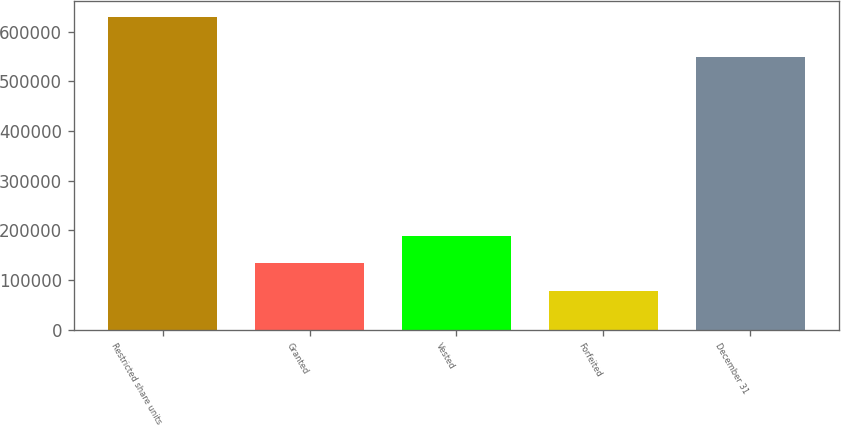Convert chart. <chart><loc_0><loc_0><loc_500><loc_500><bar_chart><fcel>Restricted share units<fcel>Granted<fcel>Vested<fcel>Forfeited<fcel>December 31<nl><fcel>630212<fcel>133838<fcel>188990<fcel>78685<fcel>548354<nl></chart> 